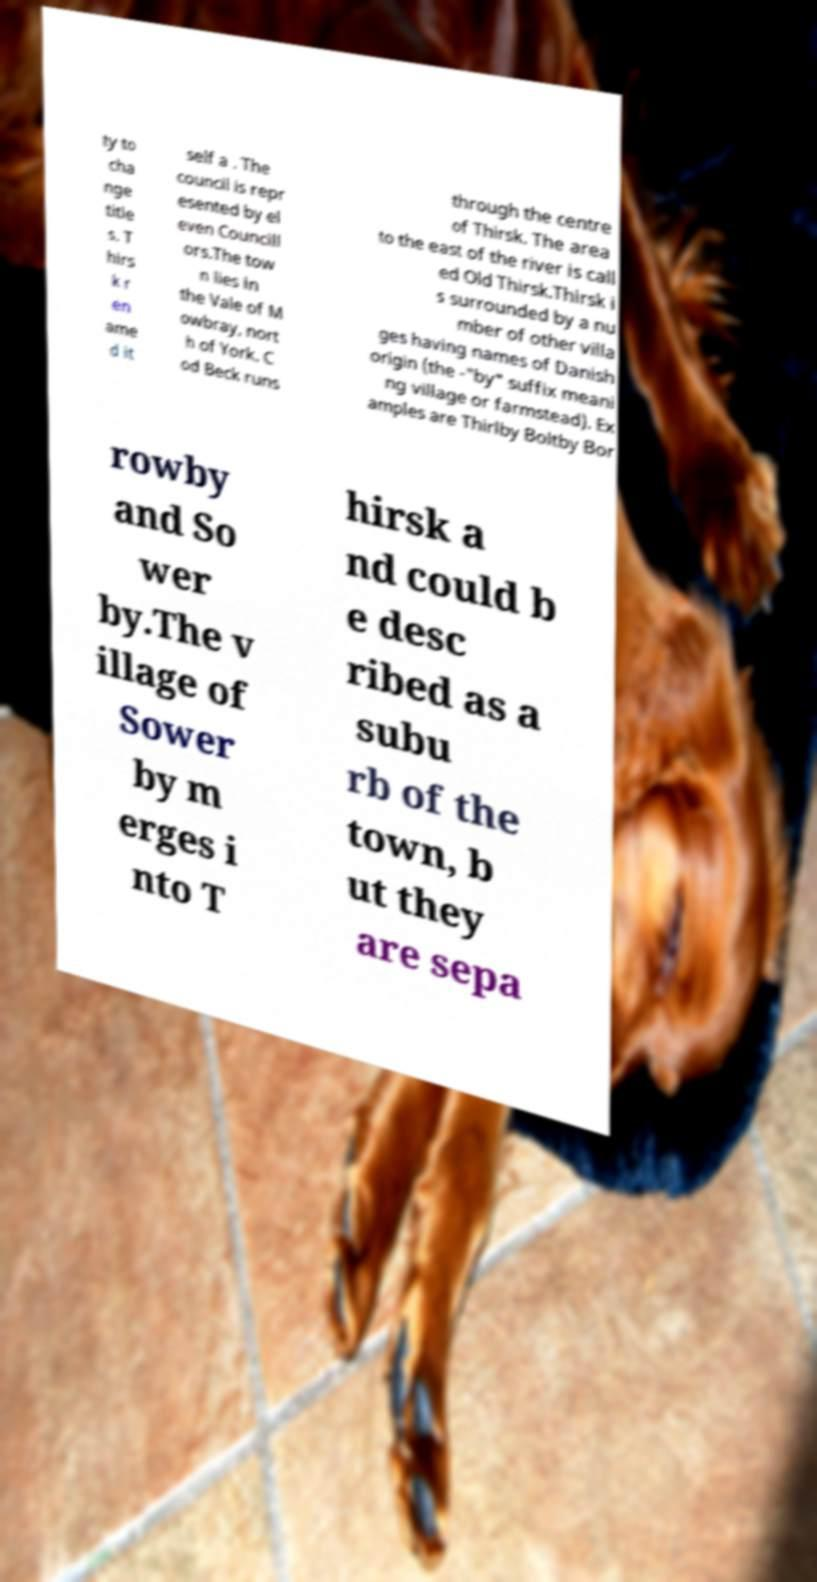Can you accurately transcribe the text from the provided image for me? ty to cha nge title s. T hirs k r en ame d it self a . The council is repr esented by el even Councill ors.The tow n lies in the Vale of M owbray, nort h of York. C od Beck runs through the centre of Thirsk. The area to the east of the river is call ed Old Thirsk.Thirsk i s surrounded by a nu mber of other villa ges having names of Danish origin (the -"by" suffix meani ng village or farmstead). Ex amples are Thirlby Boltby Bor rowby and So wer by.The v illage of Sower by m erges i nto T hirsk a nd could b e desc ribed as a subu rb of the town, b ut they are sepa 